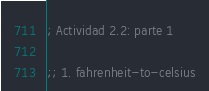<code> <loc_0><loc_0><loc_500><loc_500><_Scheme_>; Actividad 2.2: parte 1

;; 1. fahrenheit-to-celsius</code> 